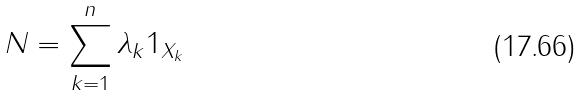<formula> <loc_0><loc_0><loc_500><loc_500>N = \sum ^ { n } _ { k = 1 } \lambda _ { k } 1 _ { X _ { k } }</formula> 